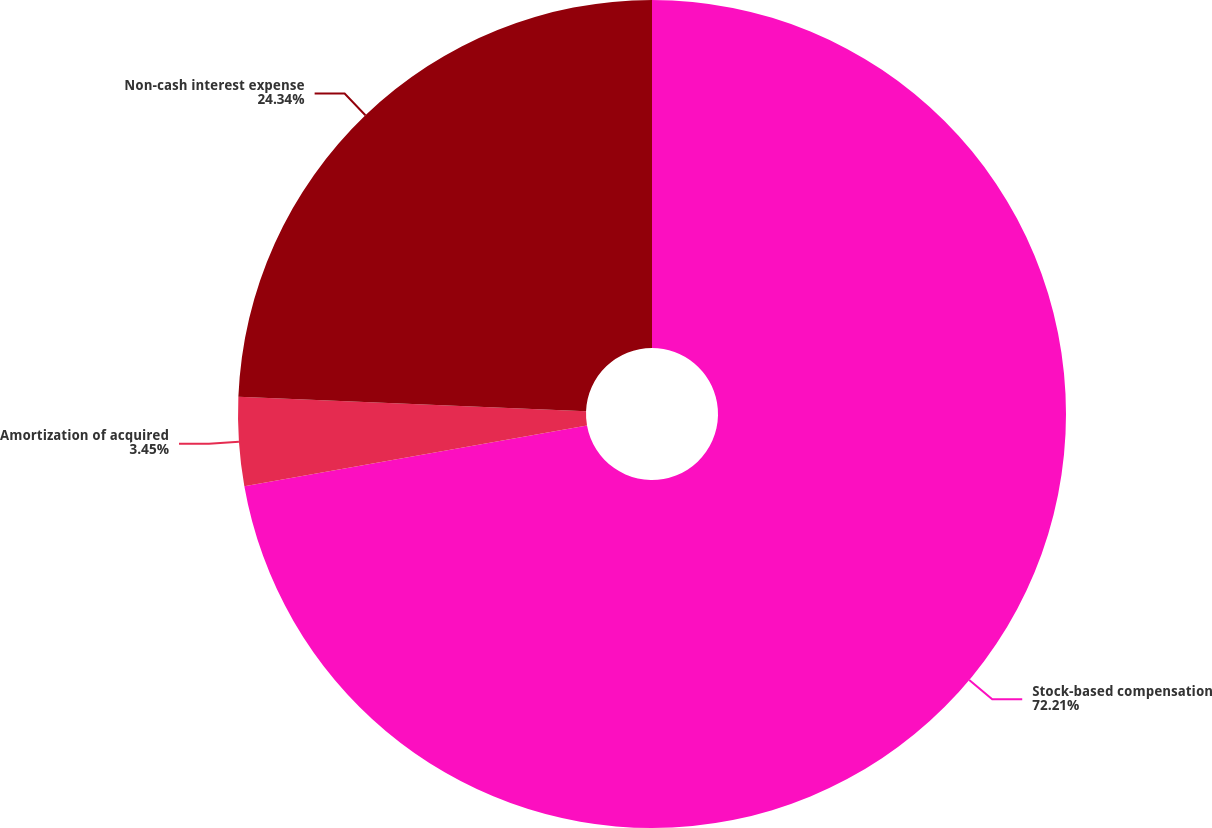Convert chart. <chart><loc_0><loc_0><loc_500><loc_500><pie_chart><fcel>Stock-based compensation<fcel>Amortization of acquired<fcel>Non-cash interest expense<nl><fcel>72.21%<fcel>3.45%<fcel>24.34%<nl></chart> 